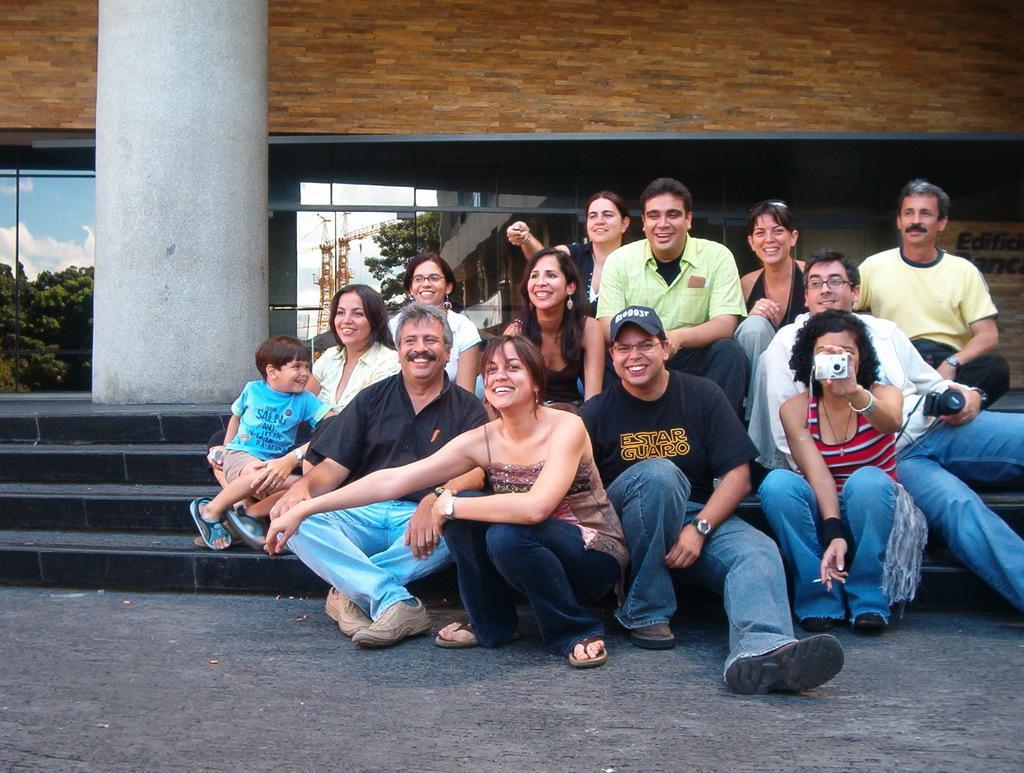Describe this image in one or two sentences. In this image we can see a group of people sitting on staircase. One person is wearing a black shirt and, spectacles and cap. One woman is holding a camera in her hand and In the background, we can see a pole and building. 